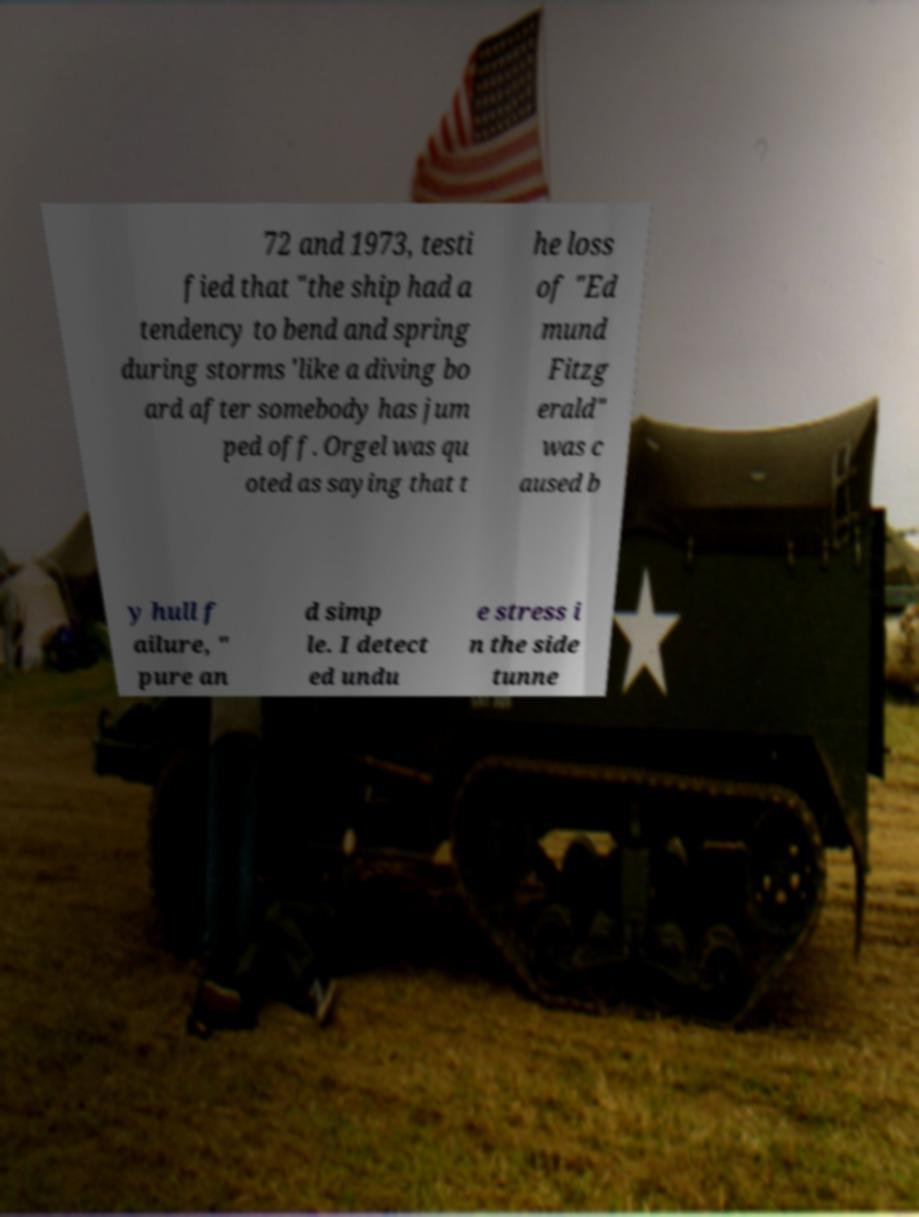Please read and relay the text visible in this image. What does it say? 72 and 1973, testi fied that "the ship had a tendency to bend and spring during storms 'like a diving bo ard after somebody has jum ped off. Orgel was qu oted as saying that t he loss of "Ed mund Fitzg erald" was c aused b y hull f ailure, " pure an d simp le. I detect ed undu e stress i n the side tunne 